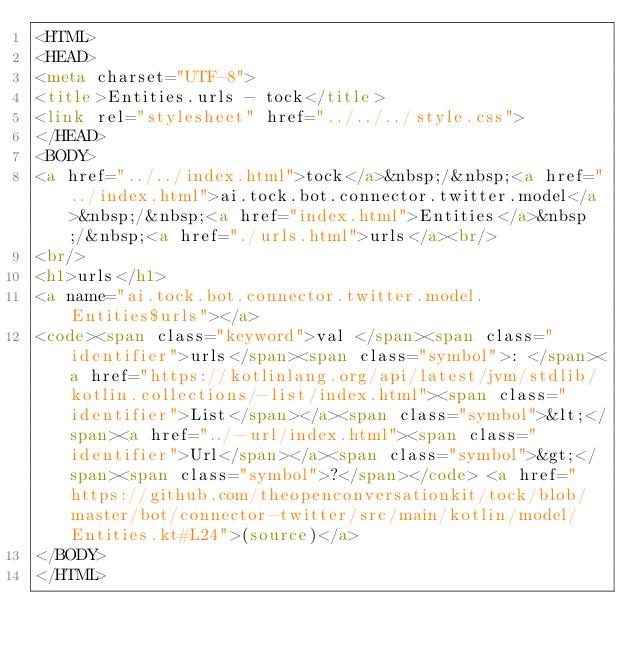<code> <loc_0><loc_0><loc_500><loc_500><_HTML_><HTML>
<HEAD>
<meta charset="UTF-8">
<title>Entities.urls - tock</title>
<link rel="stylesheet" href="../../../style.css">
</HEAD>
<BODY>
<a href="../../index.html">tock</a>&nbsp;/&nbsp;<a href="../index.html">ai.tock.bot.connector.twitter.model</a>&nbsp;/&nbsp;<a href="index.html">Entities</a>&nbsp;/&nbsp;<a href="./urls.html">urls</a><br/>
<br/>
<h1>urls</h1>
<a name="ai.tock.bot.connector.twitter.model.Entities$urls"></a>
<code><span class="keyword">val </span><span class="identifier">urls</span><span class="symbol">: </span><a href="https://kotlinlang.org/api/latest/jvm/stdlib/kotlin.collections/-list/index.html"><span class="identifier">List</span></a><span class="symbol">&lt;</span><a href="../-url/index.html"><span class="identifier">Url</span></a><span class="symbol">&gt;</span><span class="symbol">?</span></code> <a href="https://github.com/theopenconversationkit/tock/blob/master/bot/connector-twitter/src/main/kotlin/model/Entities.kt#L24">(source)</a>
</BODY>
</HTML>
</code> 